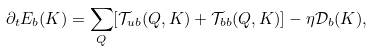<formula> <loc_0><loc_0><loc_500><loc_500>\partial _ { t } { E } _ { b } ( K ) = \sum _ { Q } [ { \mathcal { T } } _ { u b } ( Q , K ) + { \mathcal { T } } _ { b b } ( Q , K ) ] - \eta { \mathcal { D } } _ { b } ( K ) ,</formula> 